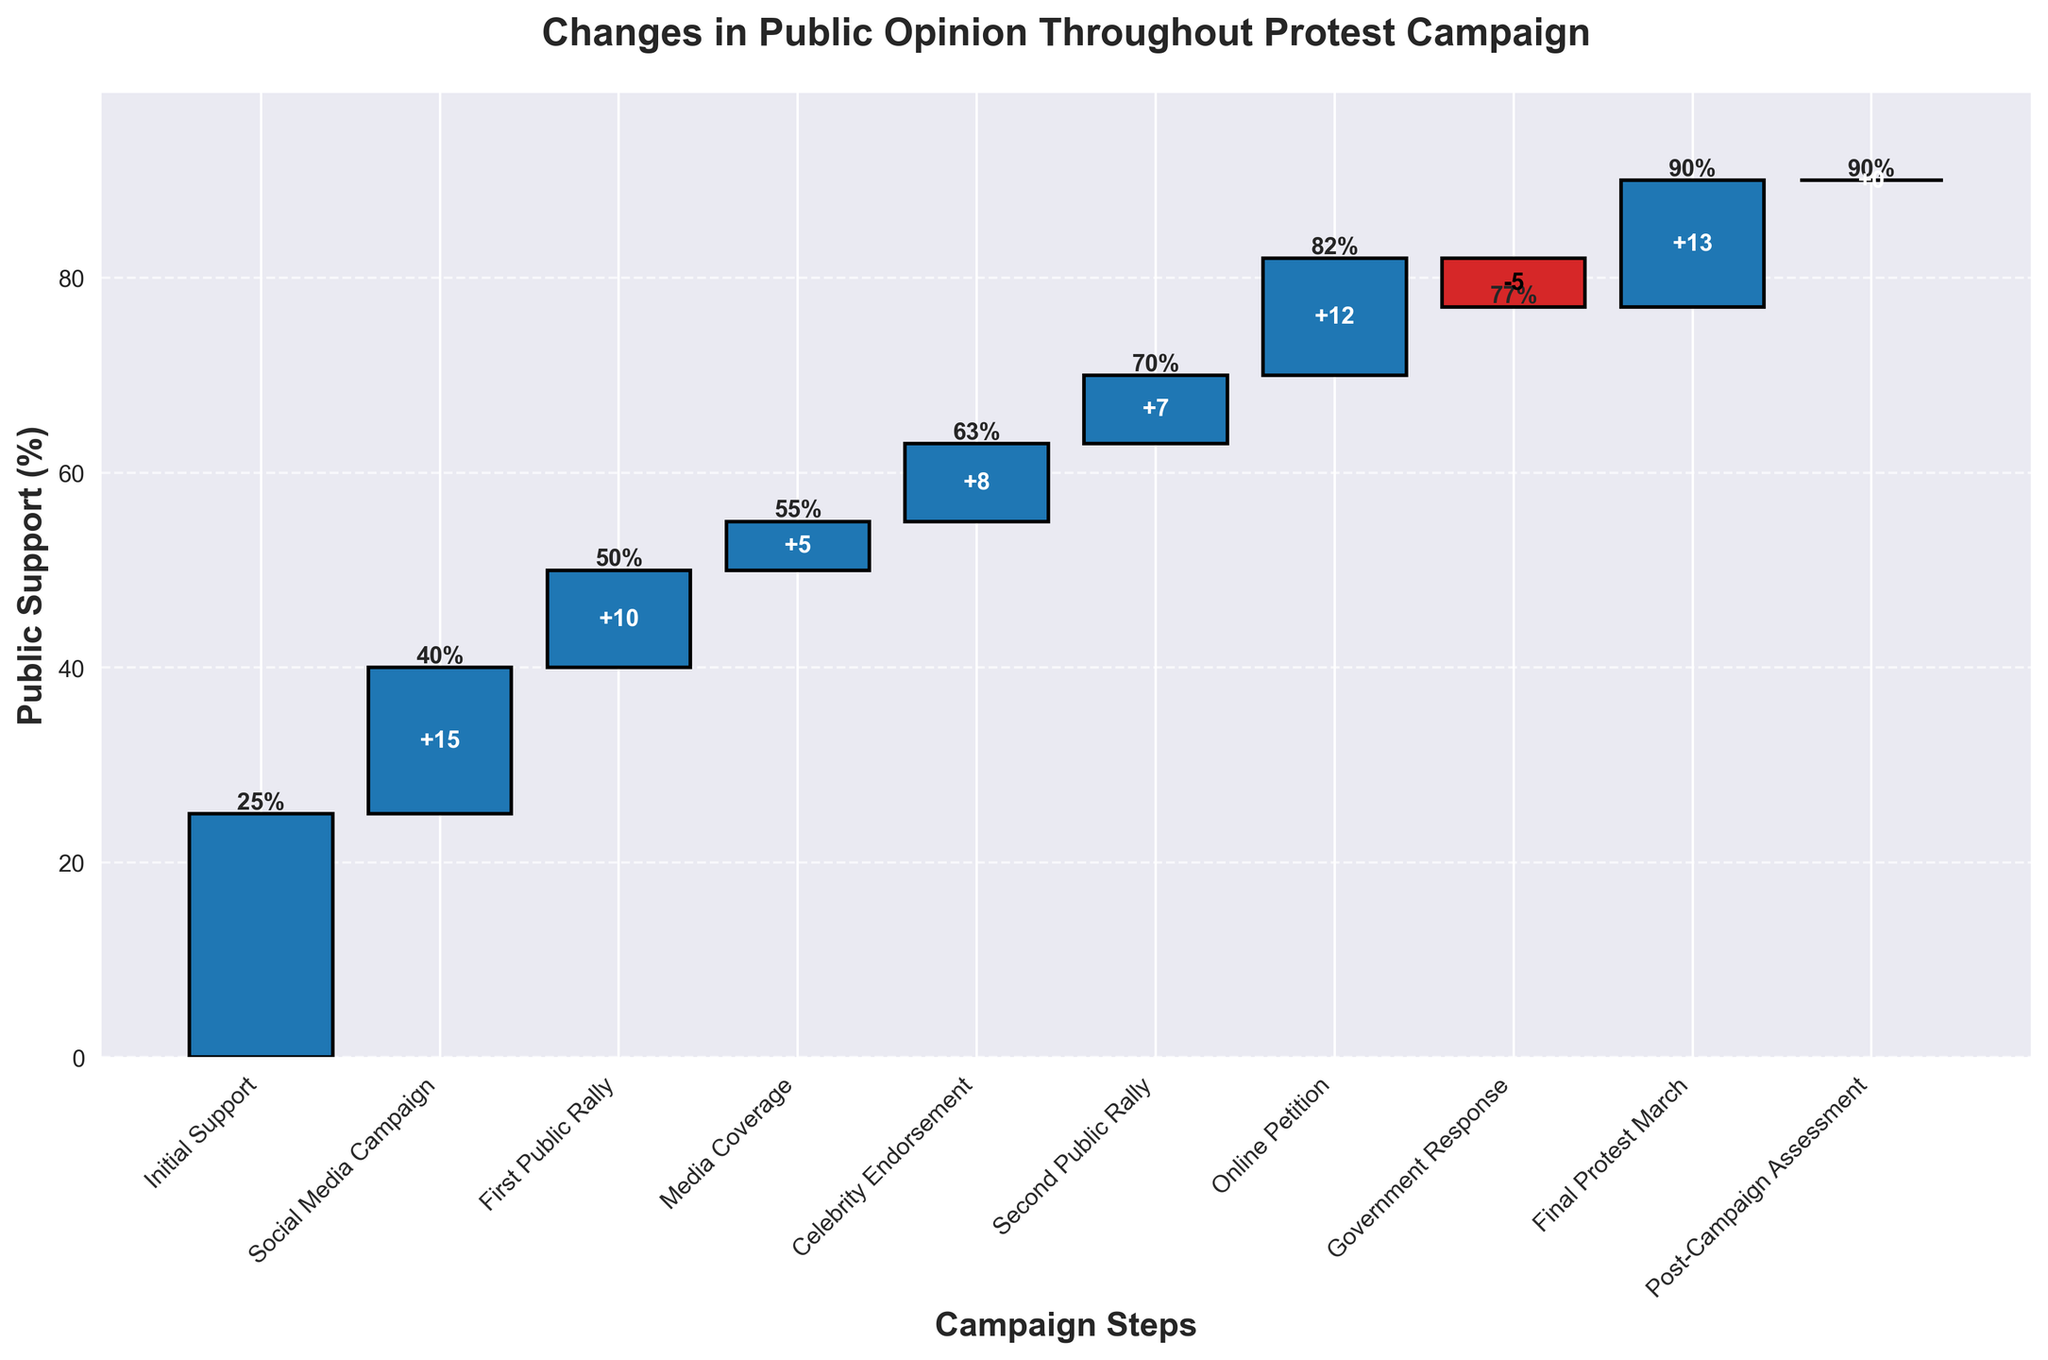What is the initial public support percentage? The initial public support percentage is given directly at the beginning of the chart.
Answer: 25% How did the social media campaign affect public support? The social media campaign increased public support. The change is shown by the height of the bar relative to the initial support, which is an increase of 15%.
Answer: Increased by 15% What was the overall change in public support after the first public rally? The support increased from its previous value to 50%. The increase from the support right before the rally (40%) to the support right after the rally (50%) is a 10% increase.
Answer: Increased by 10% Which campaign step resulted in the largest increase in public support? By comparing the height of each incremental bar, the online petition step shows the largest increase, which is 12%.
Answer: Online Petition What was the public support percentage after media coverage? According to the chart, public support was at 55% after the media coverage step.
Answer: 55% What is the net change in public support from the beginning to the post-campaign assessment? The initial support was 25%, and the post-campaign assessment shows 90%. Thus, the net change is 90% - 25% = 65%.
Answer: 65% How did the government response impact public support? The government response resulted in a decrease in public support by 5%, which can be seen from the negative change bar following this step.
Answer: Decreased by 5% How do the support changes at both public rallies compare? The first public rally increased support by 10% and the second increased it by 7%. Therefore, the first public rally had a greater impact.
Answer: First rally: 10%, Second rally: 7% What would be the percentage increase in public support if the government response had not occurred? Without the government response, the support would have remained 82% (before the response). With the final protest march (+13%), it would have been 82% + 13% = 95%.
Answer: 95% Which step does not alter public support? The Post-Campaign Assessment step has a change of 0%, indicating no change in public support.
Answer: Post-Campaign Assessment 